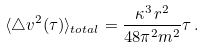Convert formula to latex. <formula><loc_0><loc_0><loc_500><loc_500>\langle \triangle v ^ { 2 } ( \tau ) \rangle _ { t o t a l } = \frac { \kappa ^ { 3 } \, r ^ { 2 } } { 4 8 \pi ^ { 2 } m ^ { 2 } } \tau \, .</formula> 